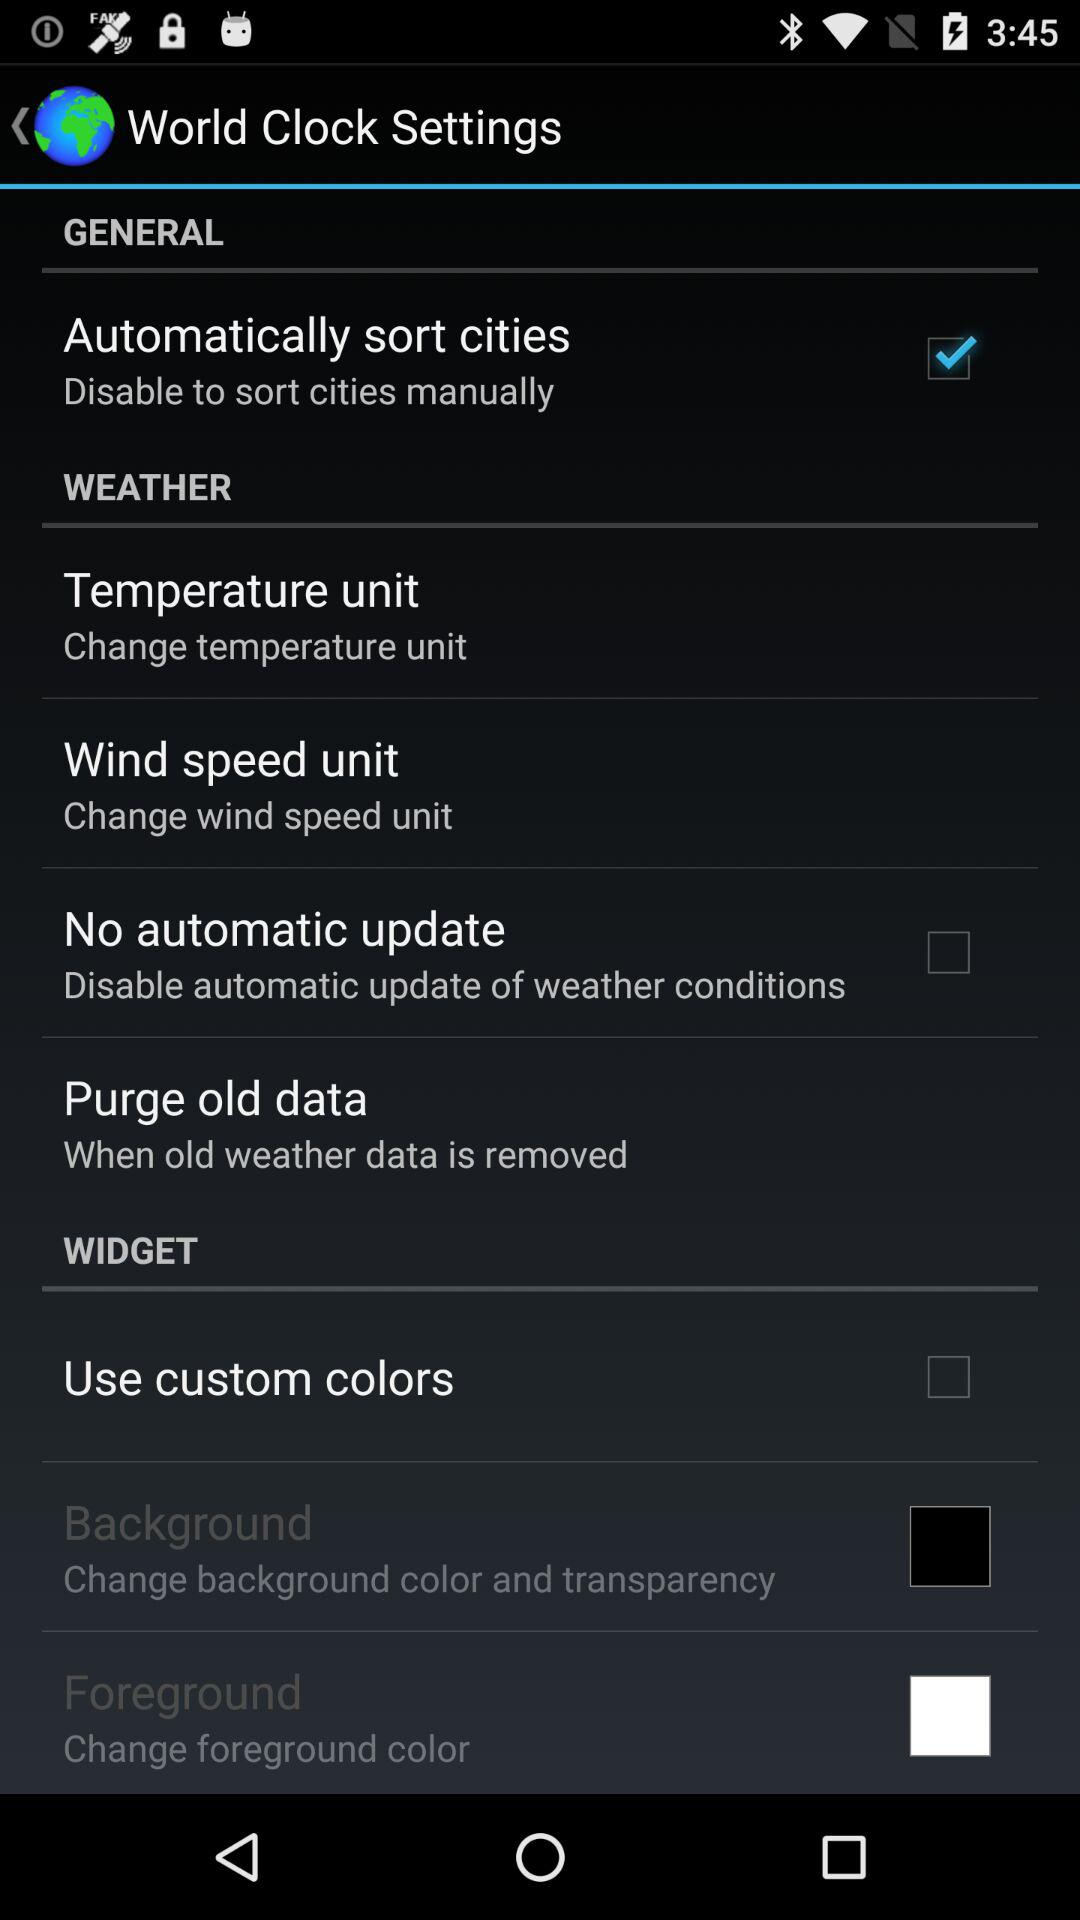Is "No automatic update" checked or unchecked? "No automatic update" is unchecked. 